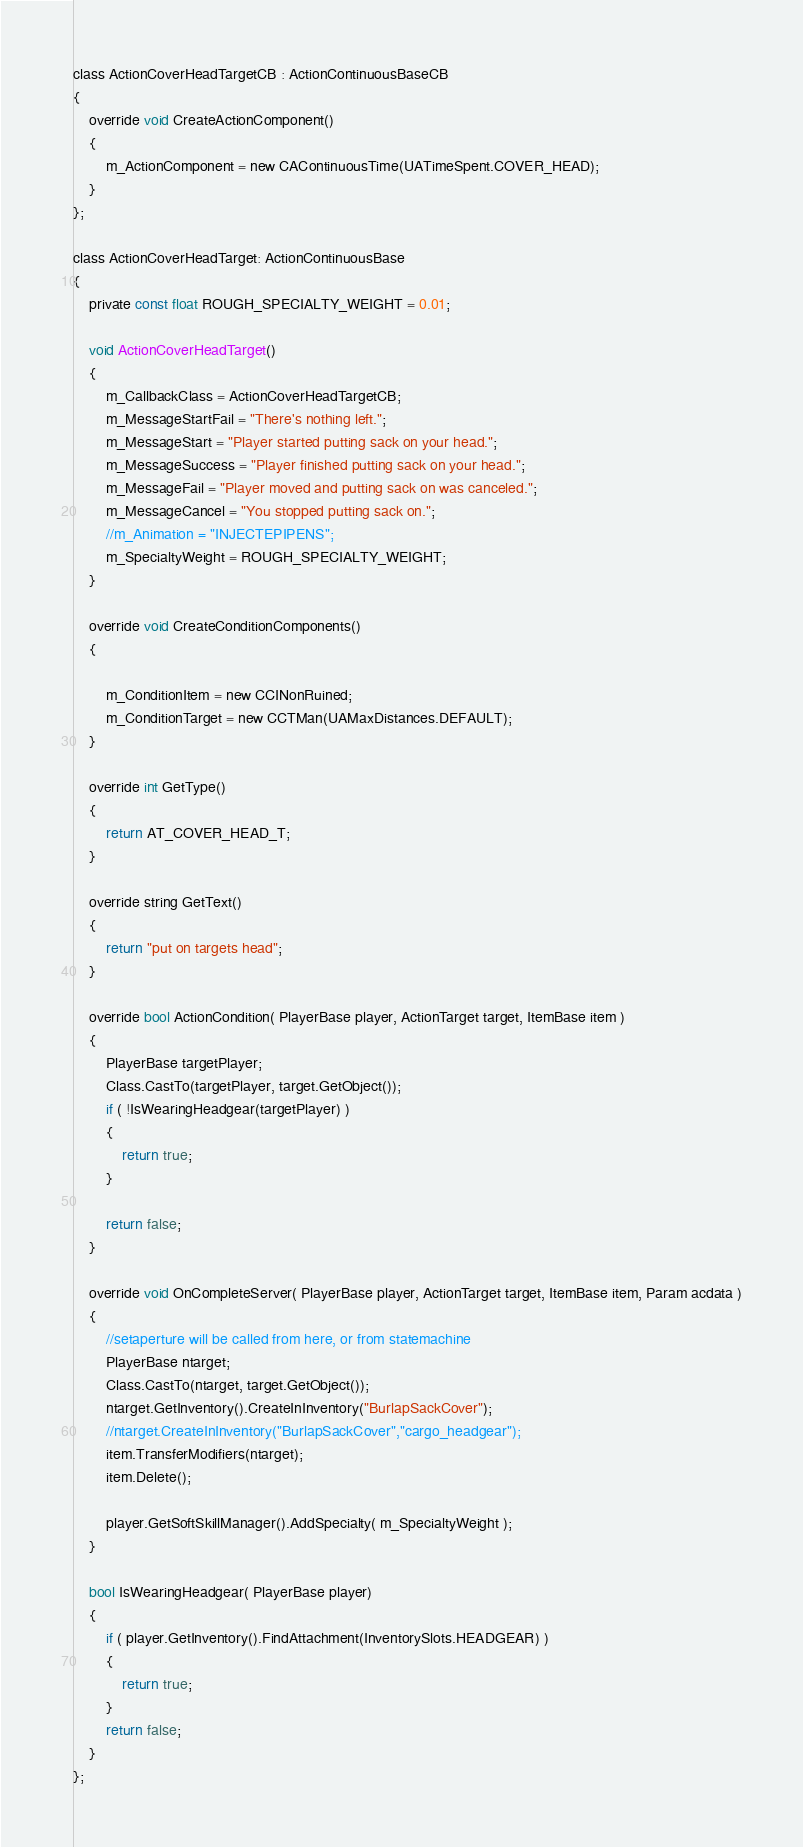<code> <loc_0><loc_0><loc_500><loc_500><_C_>class ActionCoverHeadTargetCB : ActionContinuousBaseCB
{
	override void CreateActionComponent()
	{
		m_ActionComponent = new CAContinuousTime(UATimeSpent.COVER_HEAD);
	}
};

class ActionCoverHeadTarget: ActionContinuousBase
{
	private const float ROUGH_SPECIALTY_WEIGHT = 0.01;
	
	void ActionCoverHeadTarget()
	{
		m_CallbackClass = ActionCoverHeadTargetCB;
		m_MessageStartFail = "There's nothing left.";
		m_MessageStart = "Player started putting sack on your head.";
		m_MessageSuccess = "Player finished putting sack on your head.";
		m_MessageFail = "Player moved and putting sack on was canceled.";
		m_MessageCancel = "You stopped putting sack on.";
		//m_Animation = "INJECTEPIPENS";
		m_SpecialtyWeight = ROUGH_SPECIALTY_WEIGHT;
	}
	
	override void CreateConditionComponents()  
	{	
		
		m_ConditionItem = new CCINonRuined;
		m_ConditionTarget = new CCTMan(UAMaxDistances.DEFAULT);		
	}

	override int GetType()
	{
		return AT_COVER_HEAD_T;
	}
		
	override string GetText()
	{
		return "put on targets head";
	}

	override bool ActionCondition( PlayerBase player, ActionTarget target, ItemBase item )
	{	
		PlayerBase targetPlayer;
		Class.CastTo(targetPlayer, target.GetObject());
		if ( !IsWearingHeadgear(targetPlayer) ) 
		{
			return true;
		}
		
		return false;
	}

	override void OnCompleteServer( PlayerBase player, ActionTarget target, ItemBase item, Param acdata )
	{	
		//setaperture will be called from here, or from statemachine
		PlayerBase ntarget;
		Class.CastTo(ntarget, target.GetObject());
		ntarget.GetInventory().CreateInInventory("BurlapSackCover");
		//ntarget.CreateInInventory("BurlapSackCover","cargo_headgear");
		item.TransferModifiers(ntarget);
		item.Delete();

		player.GetSoftSkillManager().AddSpecialty( m_SpecialtyWeight );
	}

	bool IsWearingHeadgear( PlayerBase player)
	{
		if ( player.GetInventory().FindAttachment(InventorySlots.HEADGEAR) )
		{
			return true;
		}
		return false;		
	}
};</code> 